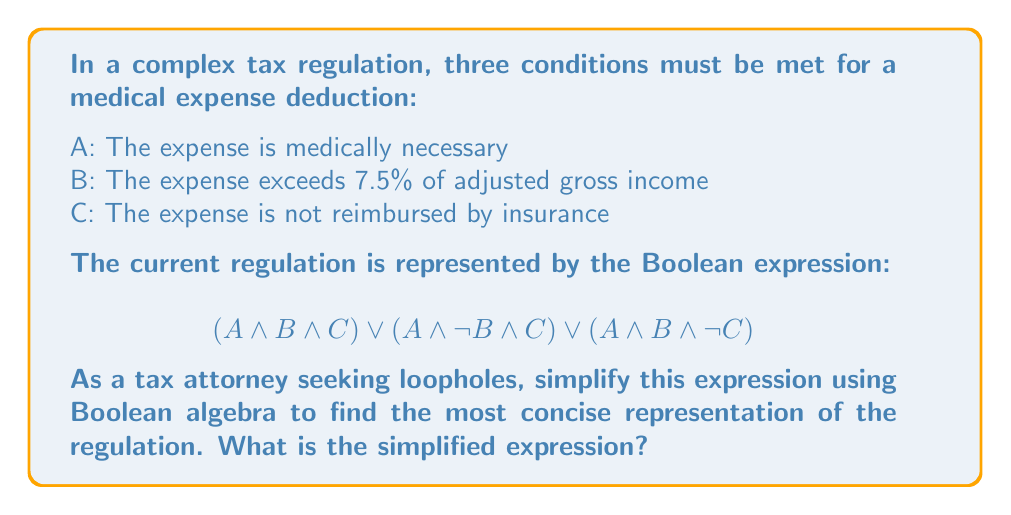Can you solve this math problem? Let's simplify the expression step by step using Boolean algebra laws:

1) Start with the given expression:
   $$(A \land B \land C) \lor (A \land \neg B \land C) \lor (A \land B \land \neg C)$$

2) Factor out A, which is common to all terms:
   $$A \land [(B \land C) \lor (\neg B \land C) \lor (B \land \neg C)]$$

3) Focus on the expression inside the square brackets:
   $$(B \land C) \lor (\neg B \land C) \lor (B \land \neg C)$$

4) Apply the distributive law to the first two terms:
   $$C \land (B \lor \neg B) \lor (B \land \neg C)$$

5) Simplify $(B \lor \neg B)$ to 1 (law of excluded middle):
   $$C \lor (B \land \neg C)$$

6) Apply the absorption law: $X \lor (Y \land \neg X) = X \lor Y$
   Therefore, $C \lor (B \land \neg C) = C \lor B$

7) Putting it all back together:
   $$A \land (C \lor B)$$

This simplified expression shows that the expense must be medically necessary (A) AND either exceed 7.5% of AGI (B) OR not be reimbursed by insurance (C).
Answer: $A \land (C \lor B)$ 